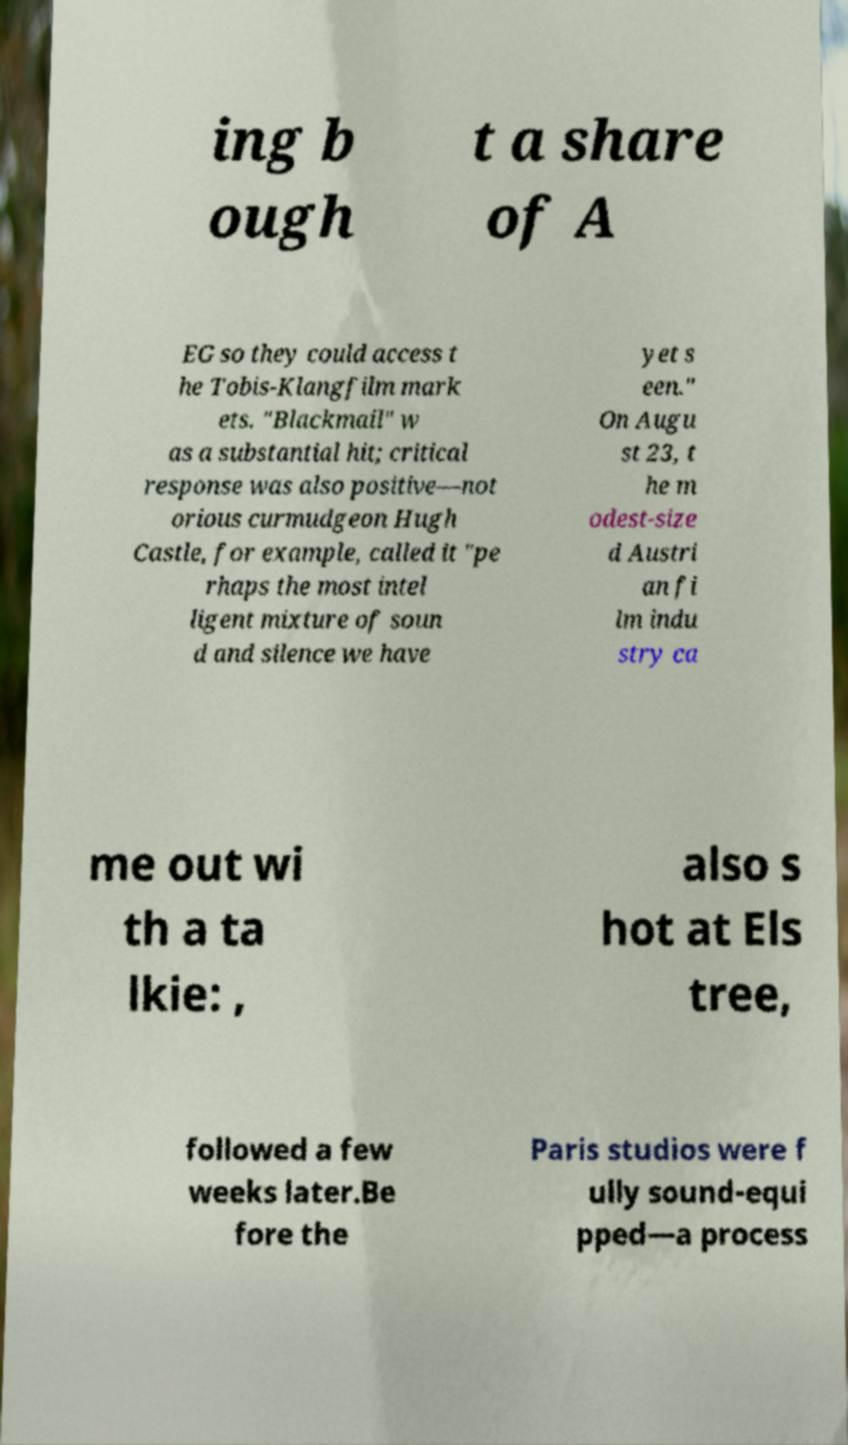What messages or text are displayed in this image? I need them in a readable, typed format. ing b ough t a share of A EG so they could access t he Tobis-Klangfilm mark ets. "Blackmail" w as a substantial hit; critical response was also positive—not orious curmudgeon Hugh Castle, for example, called it "pe rhaps the most intel ligent mixture of soun d and silence we have yet s een." On Augu st 23, t he m odest-size d Austri an fi lm indu stry ca me out wi th a ta lkie: , also s hot at Els tree, followed a few weeks later.Be fore the Paris studios were f ully sound-equi pped—a process 